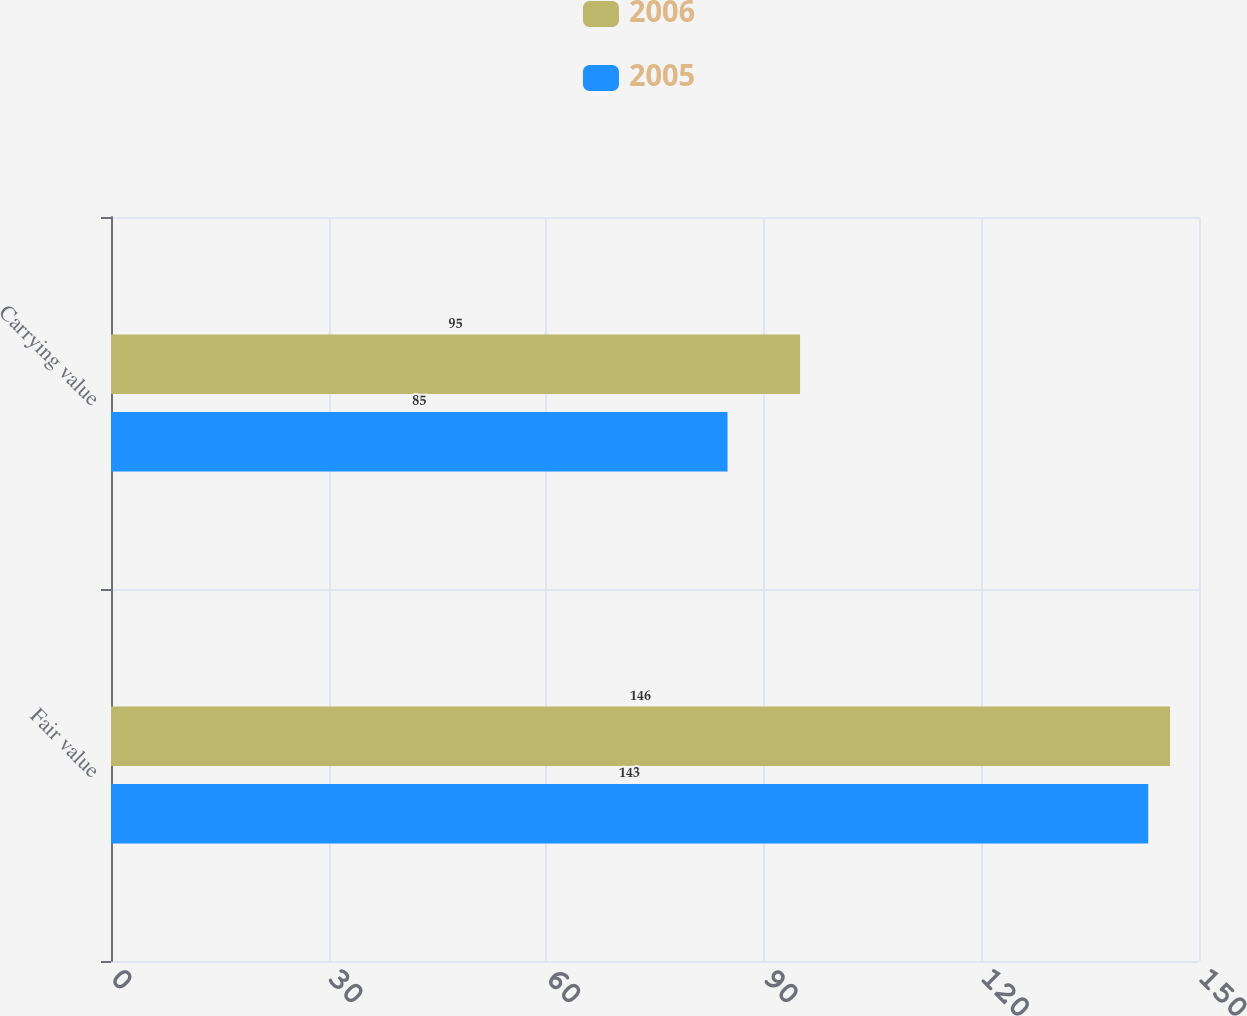Convert chart. <chart><loc_0><loc_0><loc_500><loc_500><stacked_bar_chart><ecel><fcel>Fair value<fcel>Carrying value<nl><fcel>2006<fcel>146<fcel>95<nl><fcel>2005<fcel>143<fcel>85<nl></chart> 